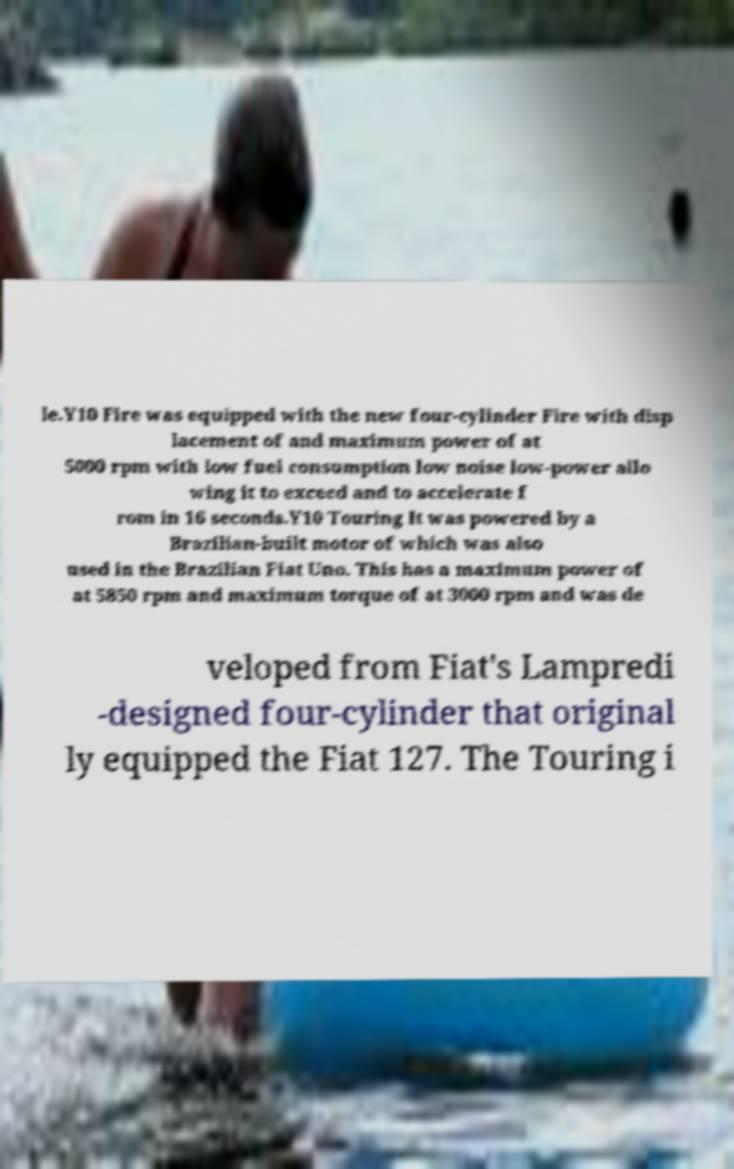I need the written content from this picture converted into text. Can you do that? le.Y10 Fire was equipped with the new four-cylinder Fire with disp lacement of and maximum power of at 5000 rpm with low fuel consumption low noise low-power allo wing it to exceed and to accelerate f rom in 16 seconds.Y10 Touring It was powered by a Brazilian-built motor of which was also used in the Brazilian Fiat Uno. This has a maximum power of at 5850 rpm and maximum torque of at 3000 rpm and was de veloped from Fiat's Lampredi -designed four-cylinder that original ly equipped the Fiat 127. The Touring i 